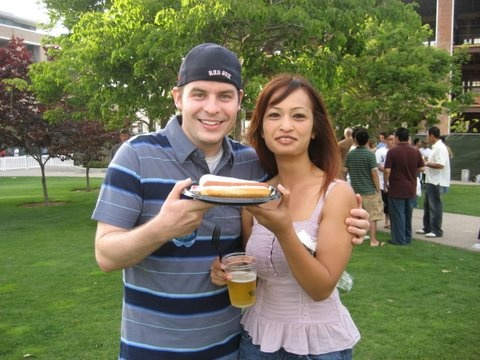Describe the objects in this image and their specific colors. I can see people in white, gray, black, and tan tones, people in white, gray, darkgray, and tan tones, people in white, black, maroon, darkblue, and gray tones, people in white, black, lightgray, gray, and darkgray tones, and people in white, black, gray, and tan tones in this image. 